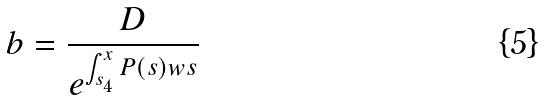Convert formula to latex. <formula><loc_0><loc_0><loc_500><loc_500>b = \frac { D } { e ^ { \int _ { s _ { 4 } } ^ { x } P ( s ) w s } }</formula> 